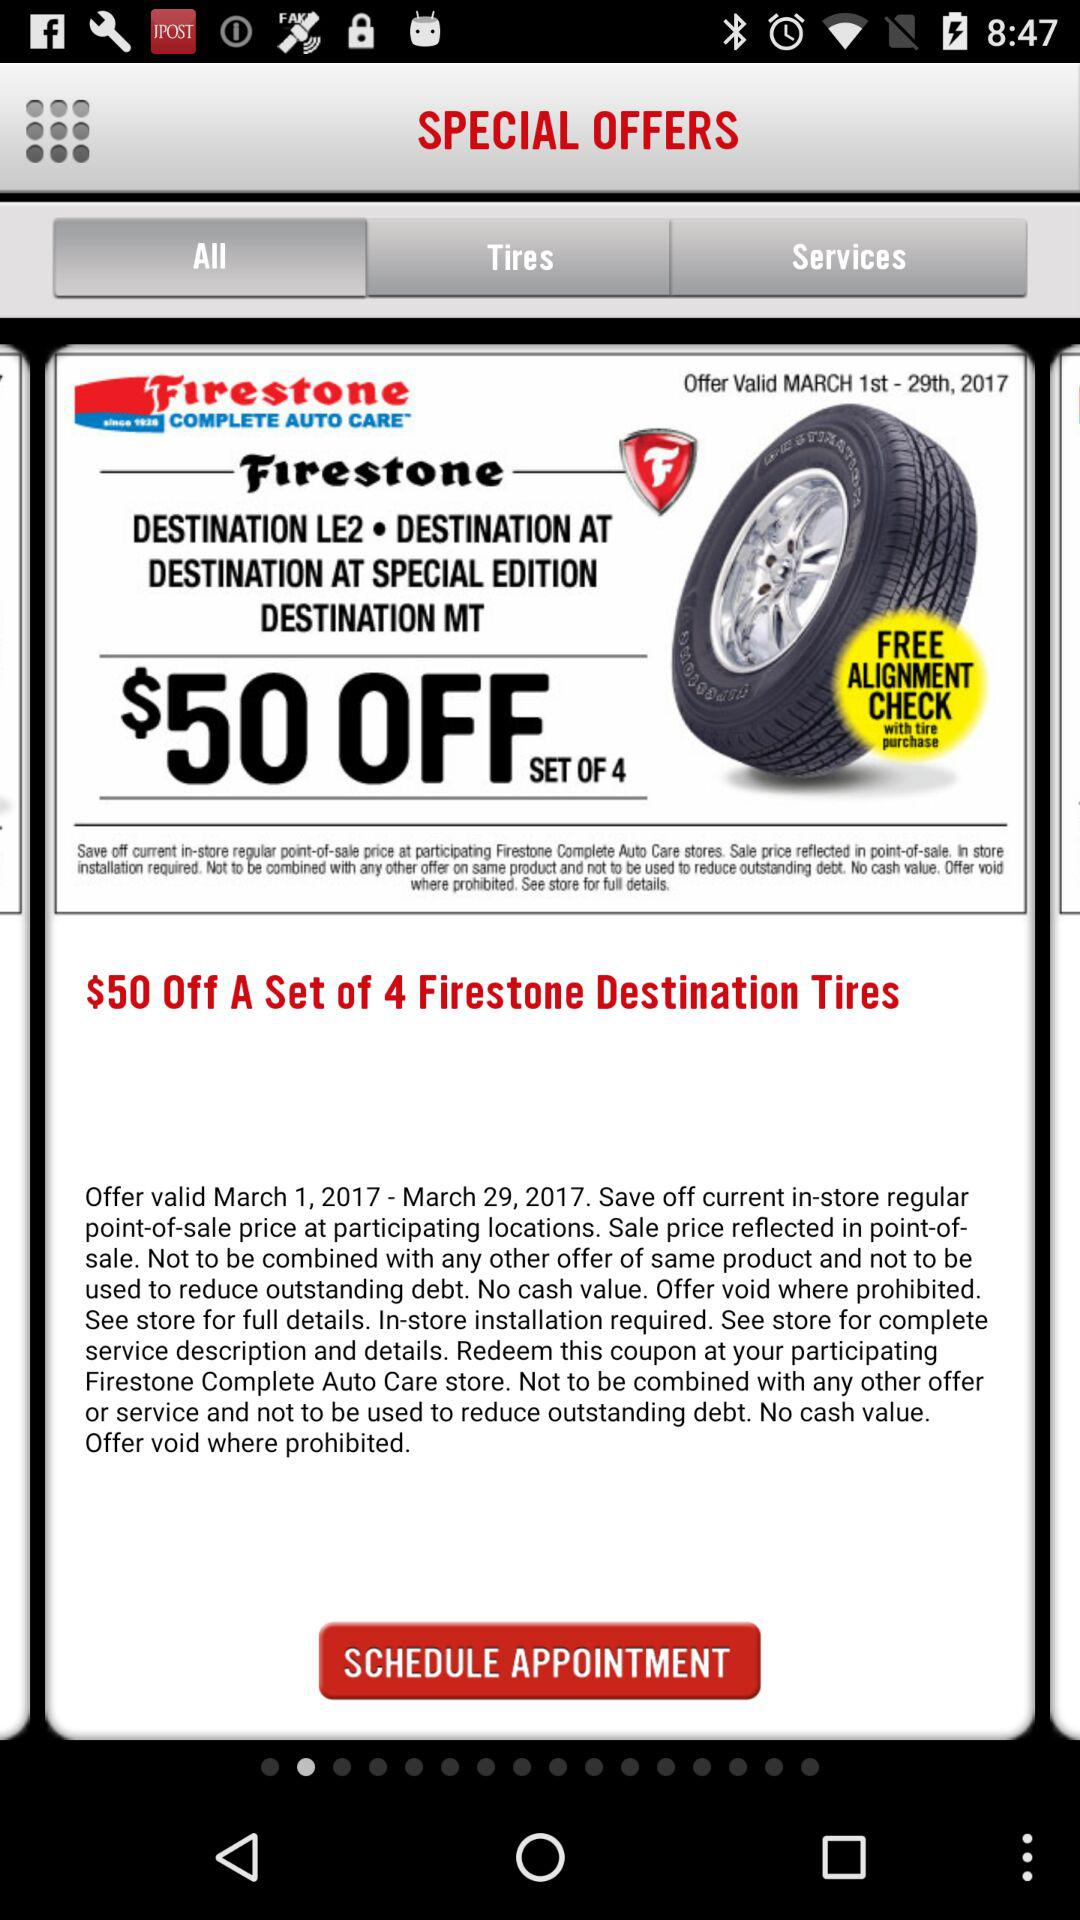Which tab has been selected? The tab "All" has been selected. 